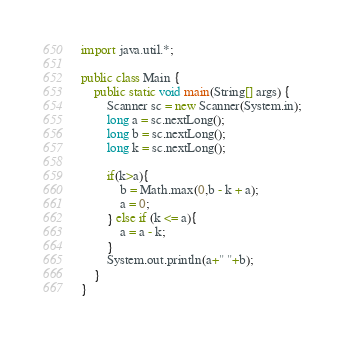Convert code to text. <code><loc_0><loc_0><loc_500><loc_500><_Java_>import java.util.*;

public class Main {
    public static void main(String[] args) {
        Scanner sc = new Scanner(System.in);
        long a = sc.nextLong();
        long b = sc.nextLong();
        long k = sc.nextLong();

        if(k>a){
            b = Math.max(0,b - k + a);
            a = 0;
        } else if (k <= a){
            a = a - k;
        }
        System.out.println(a+" "+b);
    }
}
</code> 